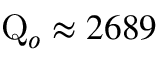<formula> <loc_0><loc_0><loc_500><loc_500>Q _ { o } \approx 2 6 8 9</formula> 